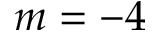<formula> <loc_0><loc_0><loc_500><loc_500>m = - 4</formula> 